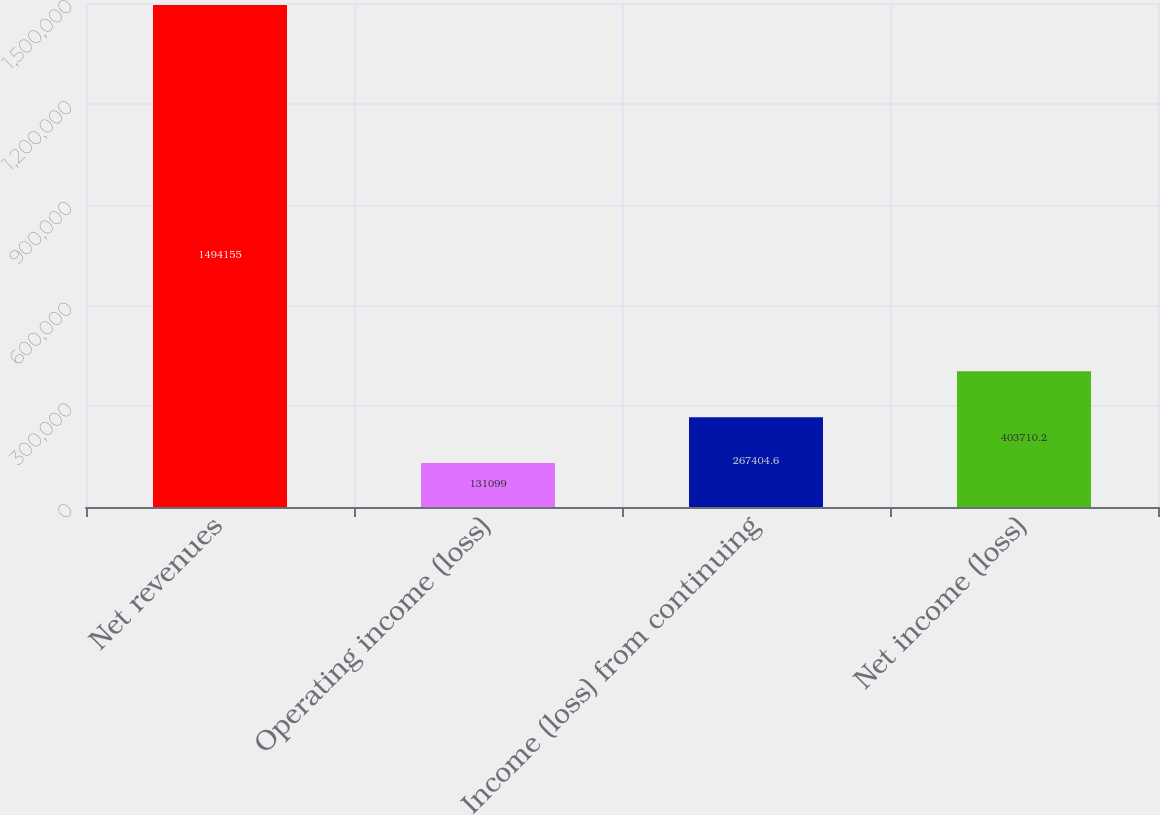Convert chart to OTSL. <chart><loc_0><loc_0><loc_500><loc_500><bar_chart><fcel>Net revenues<fcel>Operating income (loss)<fcel>Income (loss) from continuing<fcel>Net income (loss)<nl><fcel>1.49416e+06<fcel>131099<fcel>267405<fcel>403710<nl></chart> 